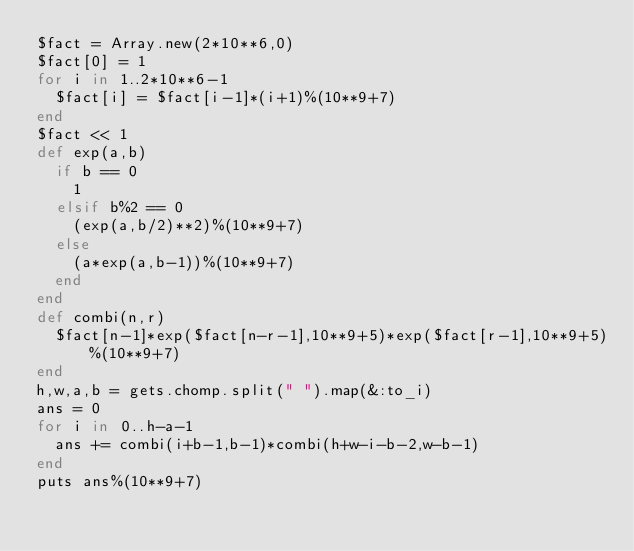Convert code to text. <code><loc_0><loc_0><loc_500><loc_500><_Ruby_>$fact = Array.new(2*10**6,0)
$fact[0] = 1
for i in 1..2*10**6-1
  $fact[i] = $fact[i-1]*(i+1)%(10**9+7)
end
$fact << 1
def exp(a,b)
  if b == 0
    1
  elsif b%2 == 0
    (exp(a,b/2)**2)%(10**9+7)
  else
    (a*exp(a,b-1))%(10**9+7)
  end
end
def combi(n,r)
  $fact[n-1]*exp($fact[n-r-1],10**9+5)*exp($fact[r-1],10**9+5)%(10**9+7)
end
h,w,a,b = gets.chomp.split(" ").map(&:to_i)
ans = 0
for i in 0..h-a-1
  ans += combi(i+b-1,b-1)*combi(h+w-i-b-2,w-b-1)
end
puts ans%(10**9+7)</code> 